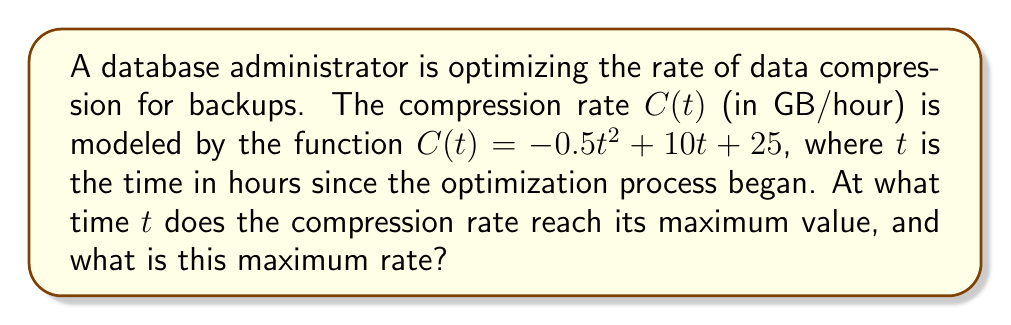Give your solution to this math problem. To find the maximum compression rate, we need to find the critical point of the function $C(t)$ and determine if it's a maximum.

Step 1: Find the derivative of $C(t)$.
$$C'(t) = -t + 10$$

Step 2: Set the derivative equal to zero and solve for $t$.
$$-t + 10 = 0$$
$$t = 10$$

Step 3: Verify this critical point is a maximum by checking the second derivative.
$$C''(t) = -1$$
Since $C''(t) < 0$ for all $t$, the critical point at $t = 10$ is indeed a maximum.

Step 4: Calculate the maximum compression rate by plugging $t = 10$ into the original function.
$$C(10) = -0.5(10)^2 + 10(10) + 25$$
$$= -50 + 100 + 25$$
$$= 75$$

Therefore, the maximum compression rate occurs at $t = 10$ hours and the rate is 75 GB/hour.
Answer: $t = 10$ hours; 75 GB/hour 